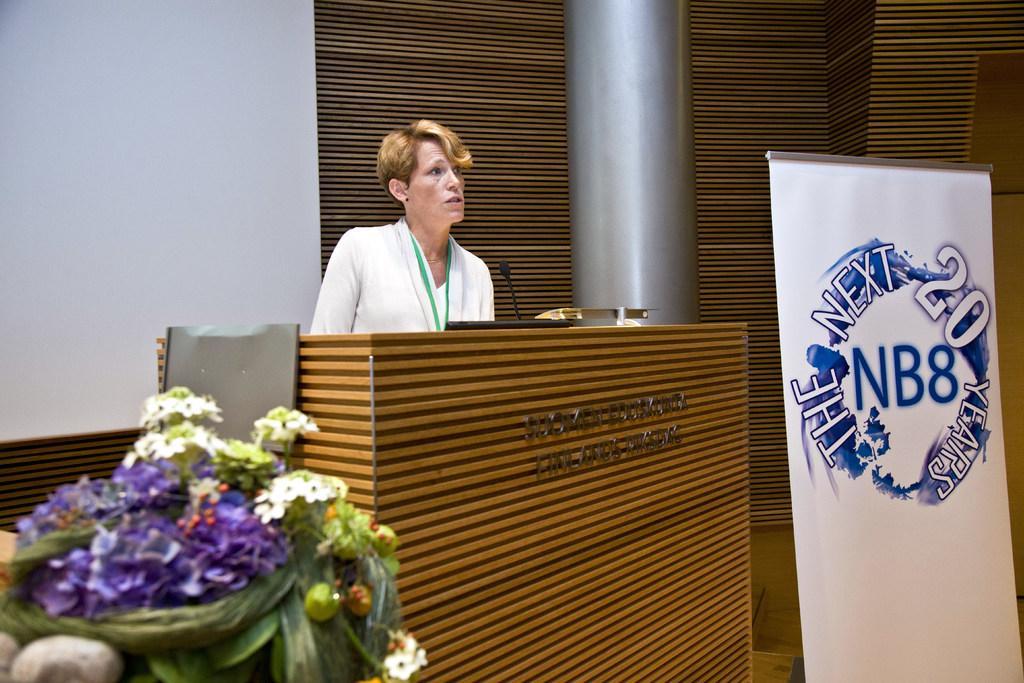Can you describe this image briefly? In this image there is a woman standing behind the podium having a mike. Left bottom there is a bouquet having flowers. Right side there is a banner having some text. Middle of the image there is a pillar. Background there is a wall. 